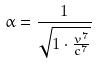<formula> <loc_0><loc_0><loc_500><loc_500>\alpha = \frac { 1 } { \sqrt { 1 \cdot \frac { v ^ { 7 } } { c ^ { 7 } } } }</formula> 